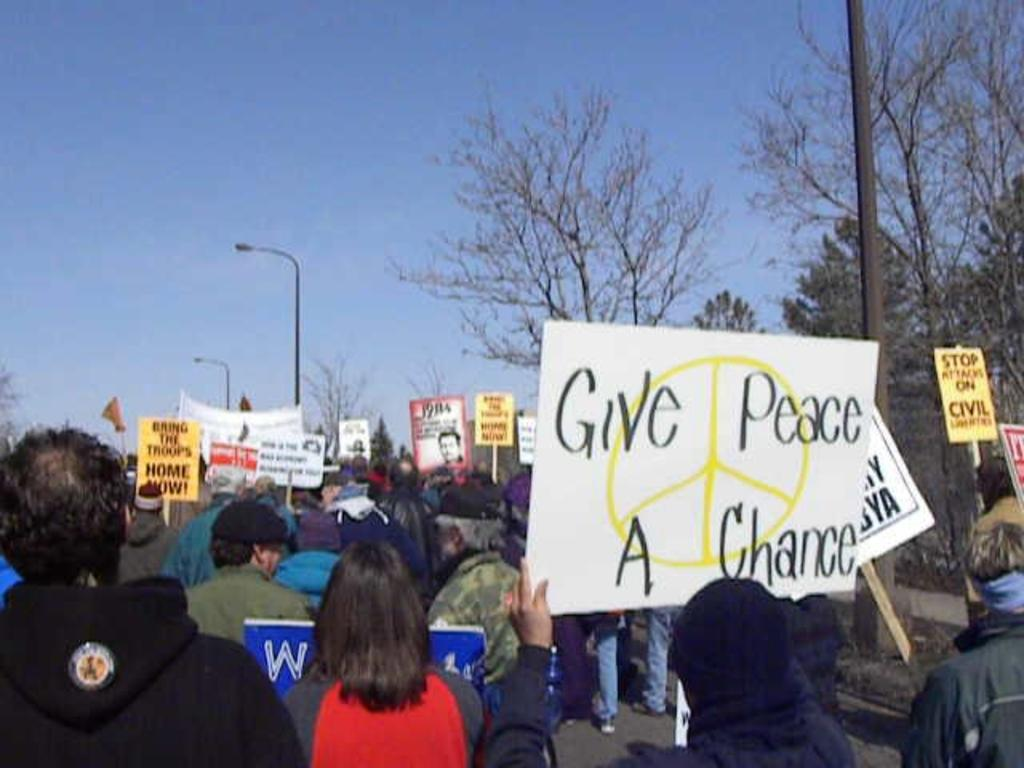<image>
Relay a brief, clear account of the picture shown. People are gathered at a protest with people holding a sign that says Give Peace a Chance. 